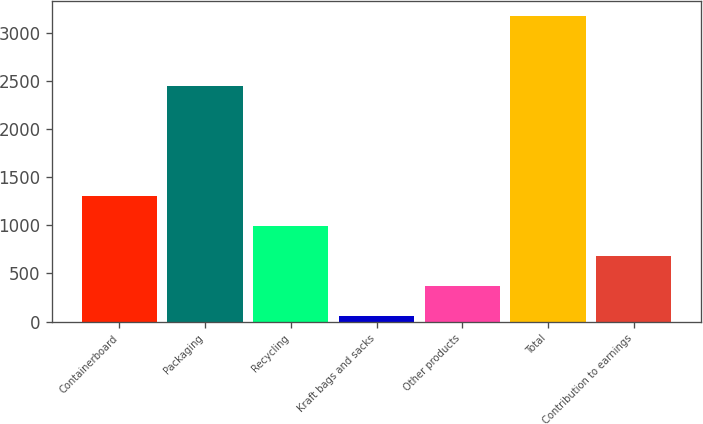Convert chart to OTSL. <chart><loc_0><loc_0><loc_500><loc_500><bar_chart><fcel>Containerboard<fcel>Packaging<fcel>Recycling<fcel>Kraft bags and sacks<fcel>Other products<fcel>Total<fcel>Contribution to earnings<nl><fcel>1301.2<fcel>2449<fcel>989.9<fcel>56<fcel>367.3<fcel>3169<fcel>678.6<nl></chart> 